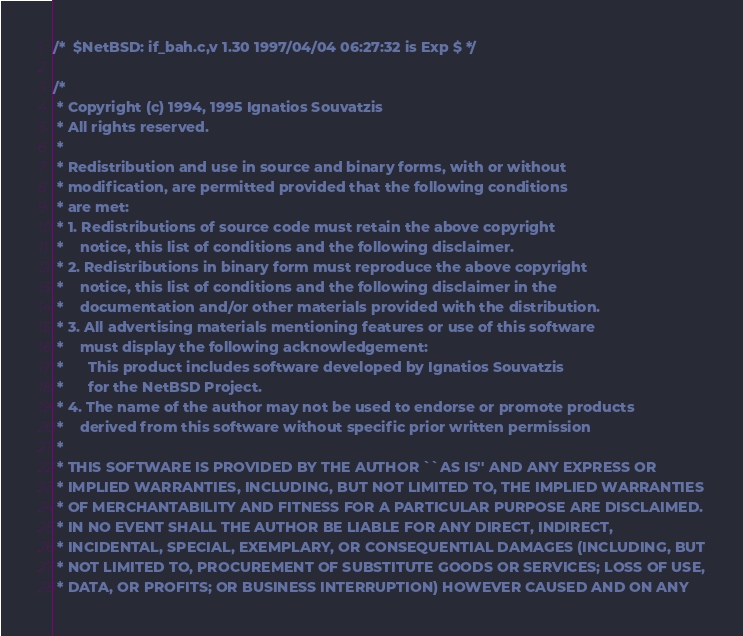<code> <loc_0><loc_0><loc_500><loc_500><_C_>/*	$NetBSD: if_bah.c,v 1.30 1997/04/04 06:27:32 is Exp $ */

/*
 * Copyright (c) 1994, 1995 Ignatios Souvatzis
 * All rights reserved.
 *
 * Redistribution and use in source and binary forms, with or without
 * modification, are permitted provided that the following conditions
 * are met:
 * 1. Redistributions of source code must retain the above copyright
 *    notice, this list of conditions and the following disclaimer.
 * 2. Redistributions in binary form must reproduce the above copyright
 *    notice, this list of conditions and the following disclaimer in the
 *    documentation and/or other materials provided with the distribution.
 * 3. All advertising materials mentioning features or use of this software
 *    must display the following acknowledgement:
 *      This product includes software developed by Ignatios Souvatzis
 *      for the NetBSD Project.
 * 4. The name of the author may not be used to endorse or promote products
 *    derived from this software without specific prior written permission
 *
 * THIS SOFTWARE IS PROVIDED BY THE AUTHOR ``AS IS'' AND ANY EXPRESS OR
 * IMPLIED WARRANTIES, INCLUDING, BUT NOT LIMITED TO, THE IMPLIED WARRANTIES
 * OF MERCHANTABILITY AND FITNESS FOR A PARTICULAR PURPOSE ARE DISCLAIMED.
 * IN NO EVENT SHALL THE AUTHOR BE LIABLE FOR ANY DIRECT, INDIRECT,
 * INCIDENTAL, SPECIAL, EXEMPLARY, OR CONSEQUENTIAL DAMAGES (INCLUDING, BUT
 * NOT LIMITED TO, PROCUREMENT OF SUBSTITUTE GOODS OR SERVICES; LOSS OF USE,
 * DATA, OR PROFITS; OR BUSINESS INTERRUPTION) HOWEVER CAUSED AND ON ANY</code> 